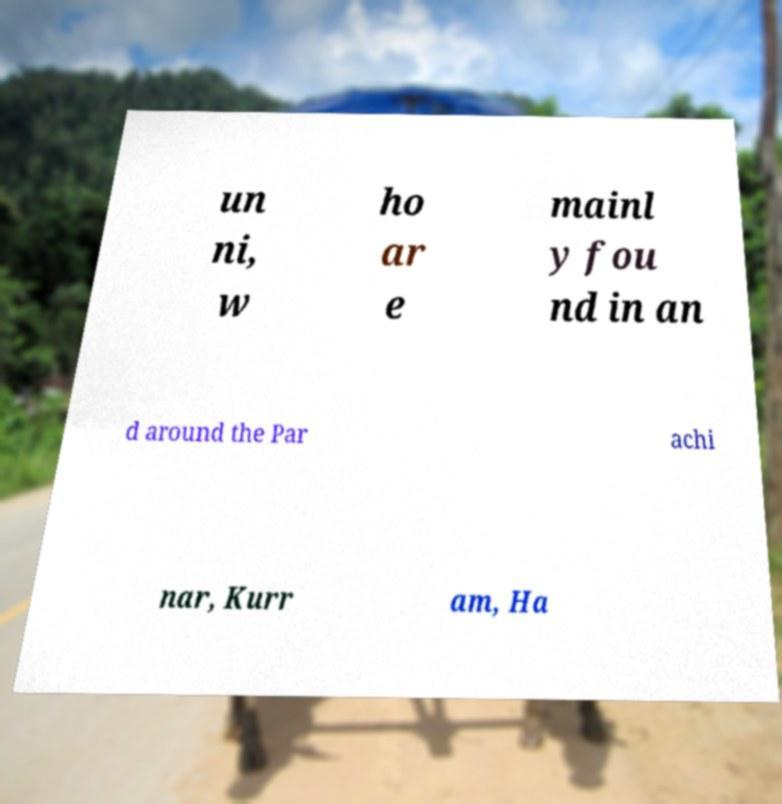There's text embedded in this image that I need extracted. Can you transcribe it verbatim? un ni, w ho ar e mainl y fou nd in an d around the Par achi nar, Kurr am, Ha 